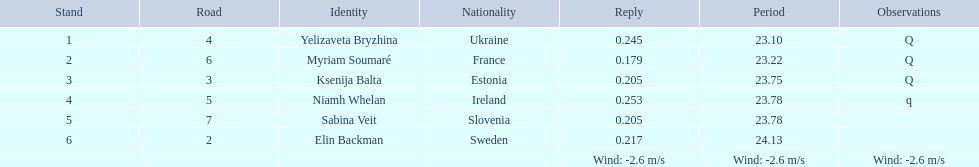Which athlete is from sweden? Elin Backman. What was their time to finish the race? 24.13. 